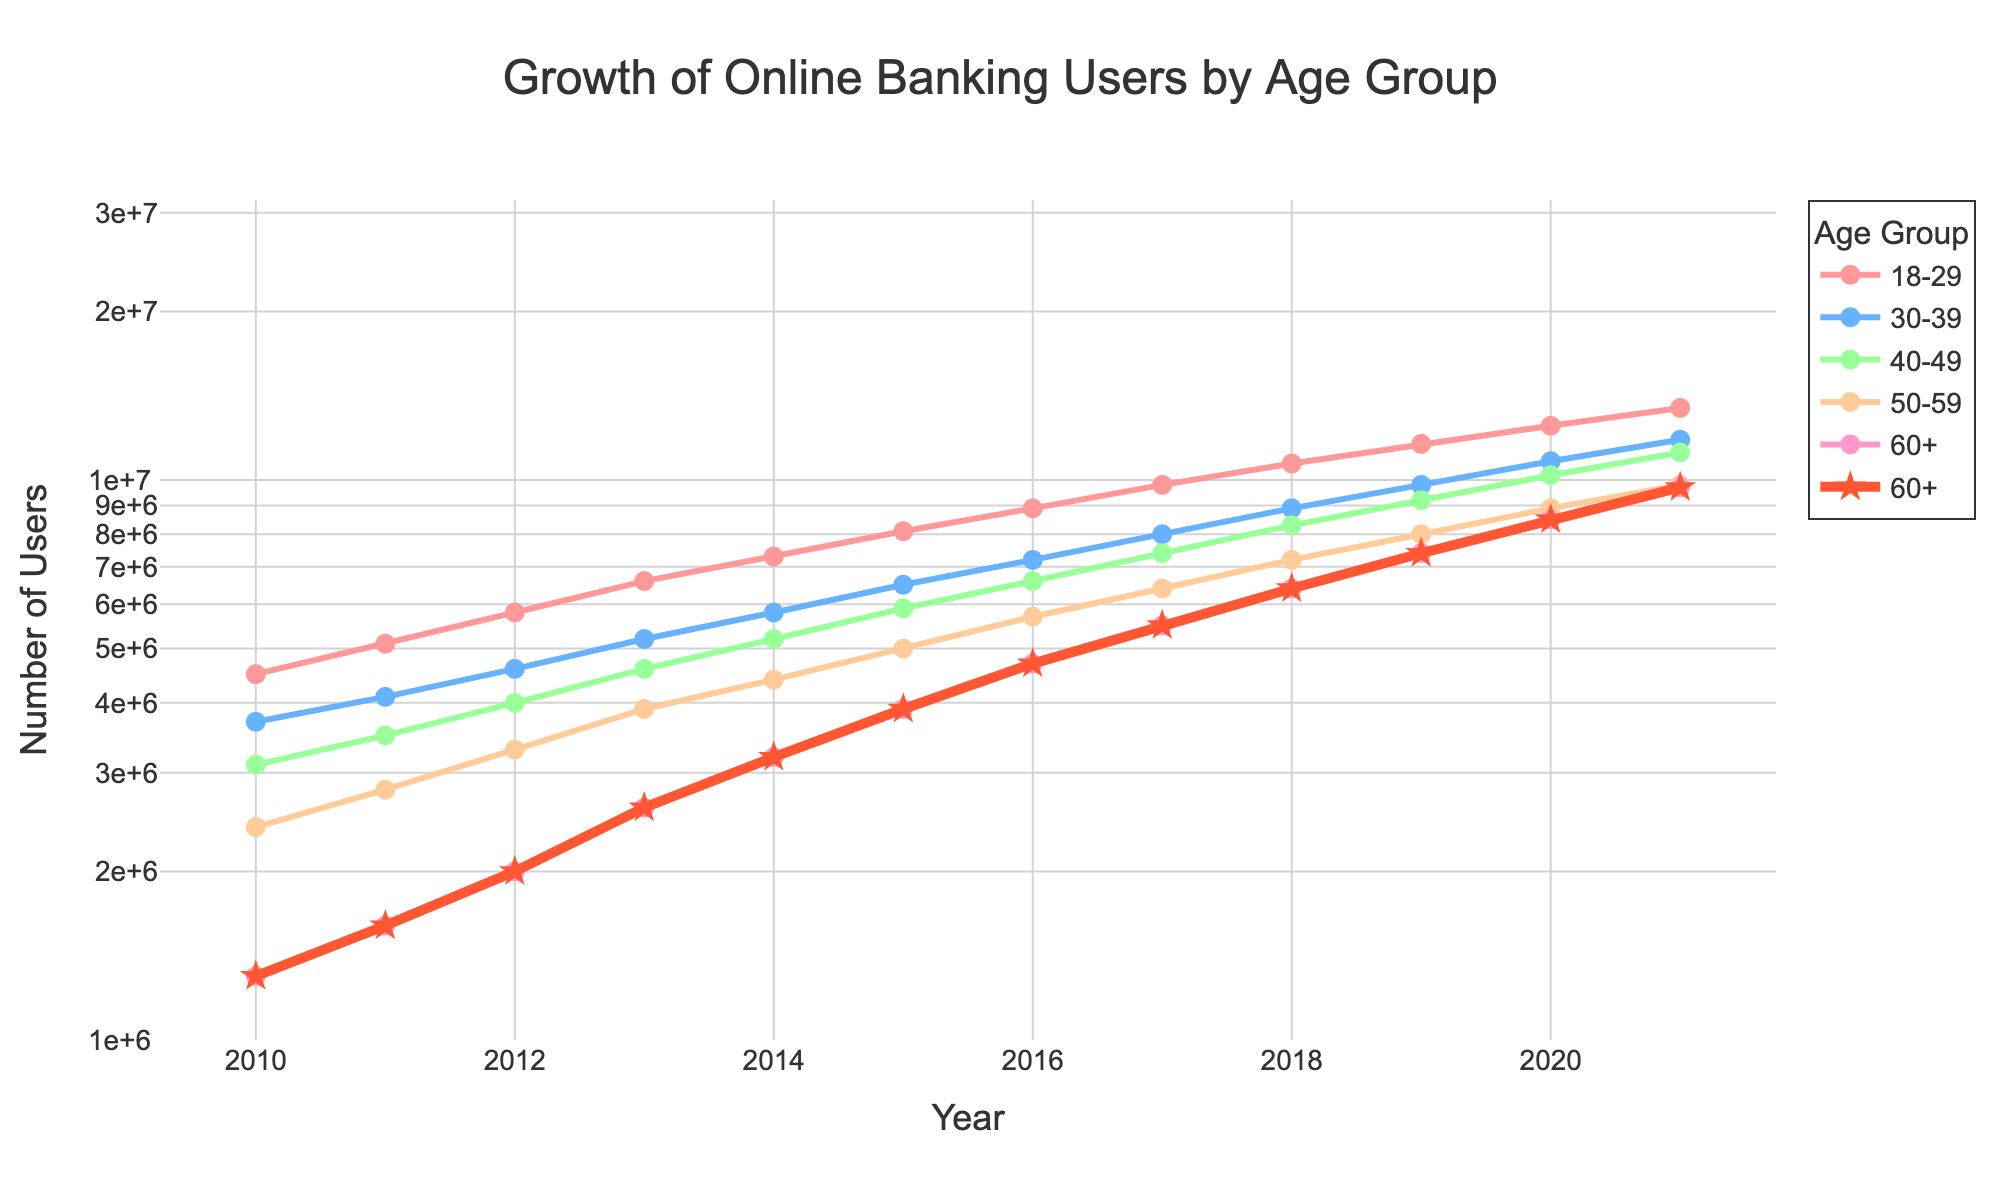What is the title of the figure? The title is displayed at the top center of the figure, which describes the main topic of the plot.
Answer: Growth of Online Banking Users by Age Group Which age group was highlighted with the thickest line and distinct marker? The thickest line and distinct marker (star) highlight the 60+ age group in the figure.
Answer: 60+ Approximately how many online banking users were there in the 60+ age group in 2020? Identify the point on the 60+ line trace corresponding to the year 2020 and read the value from the y-axis.
Answer: 8,500,000 Among all the age groups, which one had the highest number of users in 2021? Compare the values at the end points of all lines in 2021; the highest value is in the 18-29 group.
Answer: 18-29 By how much did the number of 60+ users increase from 2010 to 2021? Subtract the value for the 60+ age group in 2010 from the value in 2021: 9.7 million - 1.3 million.
Answer: 8,400,000 Which age group had a steeper increase in the number of online banking users from 2010 to 2021: 50-59 or 60+? Compare the slopes of the lines; the 60+ age group's line is steeper from 1.3 million to 9.7 million compared to 50-59, which increased from 2.4 million to 9.8 million.
Answer: 60+ What is the range of the y-axis in the plot? Check the y-axis for the minimum and maximum values given the log scale setup of the plot.
Answer: 1,000,000 to 100,000,000 Which year displayed the largest increase in users for the 30-39 age group? Find the steepest segment of the 30-39 trace, which occurs between the biggest y-values changes; between 2019 and 2020.
Answer: 2019-2020 How do the number of online banking users in the 40-49 age group compare to the 30-39 age group in 2013? Read the values of both age groups for the year 2013 and compare them, 40-49 had 4.6 million users versus 5.2 million in the 30-39 group.
Answer: Lower What trend do you observe for all age groups between 2010 and 2021? All lines show an increasing trend from the starting point in 2010 towards the end point in 2021, indicating growth for all groups.
Answer: Increasing 